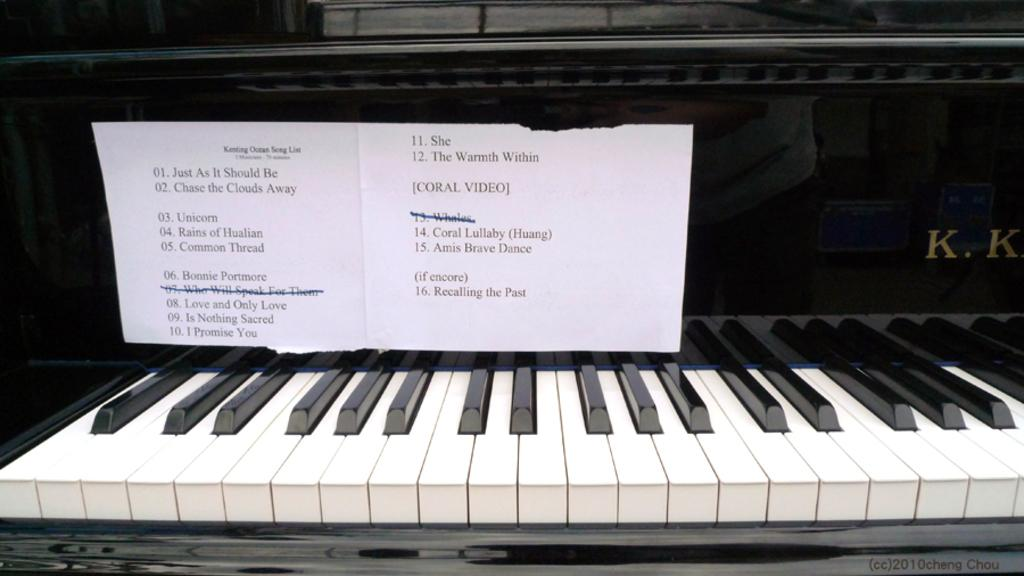What is there is a musical instrument in the image, what is it? There is a piano in the image. Is there anything attached or placed on the piano? Yes, a white color paper is sticked on the piano. What type of plot is visible in the image? There is no plot visible in the image, as it features a piano with a white color paper sticked on it. 